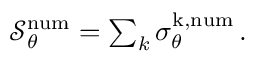Convert formula to latex. <formula><loc_0><loc_0><loc_500><loc_500>\begin{array} { r } { \mathcal { S } _ { \theta } ^ { n u m } = \sum _ { k } \sigma _ { \theta } ^ { k , n u m } \, . } \end{array}</formula> 